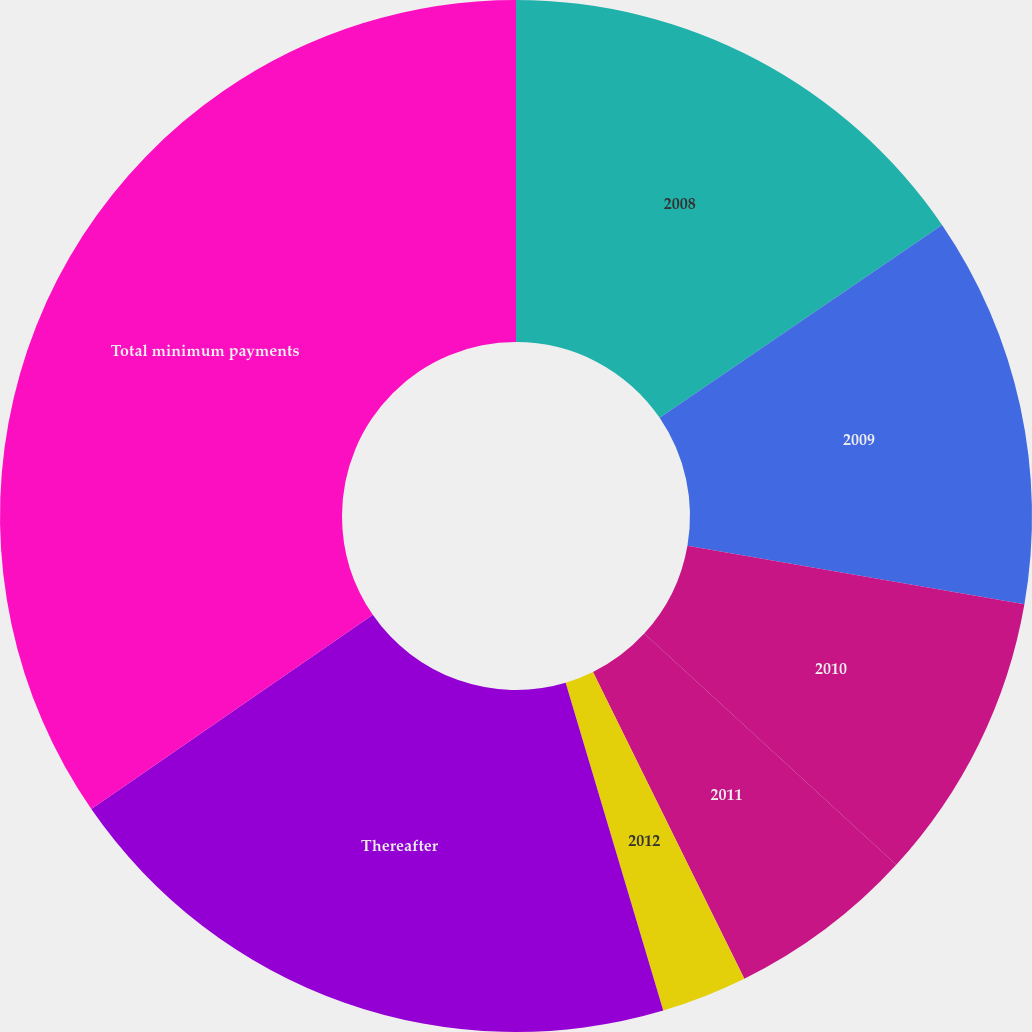Convert chart. <chart><loc_0><loc_0><loc_500><loc_500><pie_chart><fcel>2008<fcel>2009<fcel>2010<fcel>2011<fcel>2012<fcel>Thereafter<fcel>Total minimum payments<nl><fcel>15.46%<fcel>12.27%<fcel>9.08%<fcel>5.89%<fcel>2.69%<fcel>19.99%<fcel>34.61%<nl></chart> 